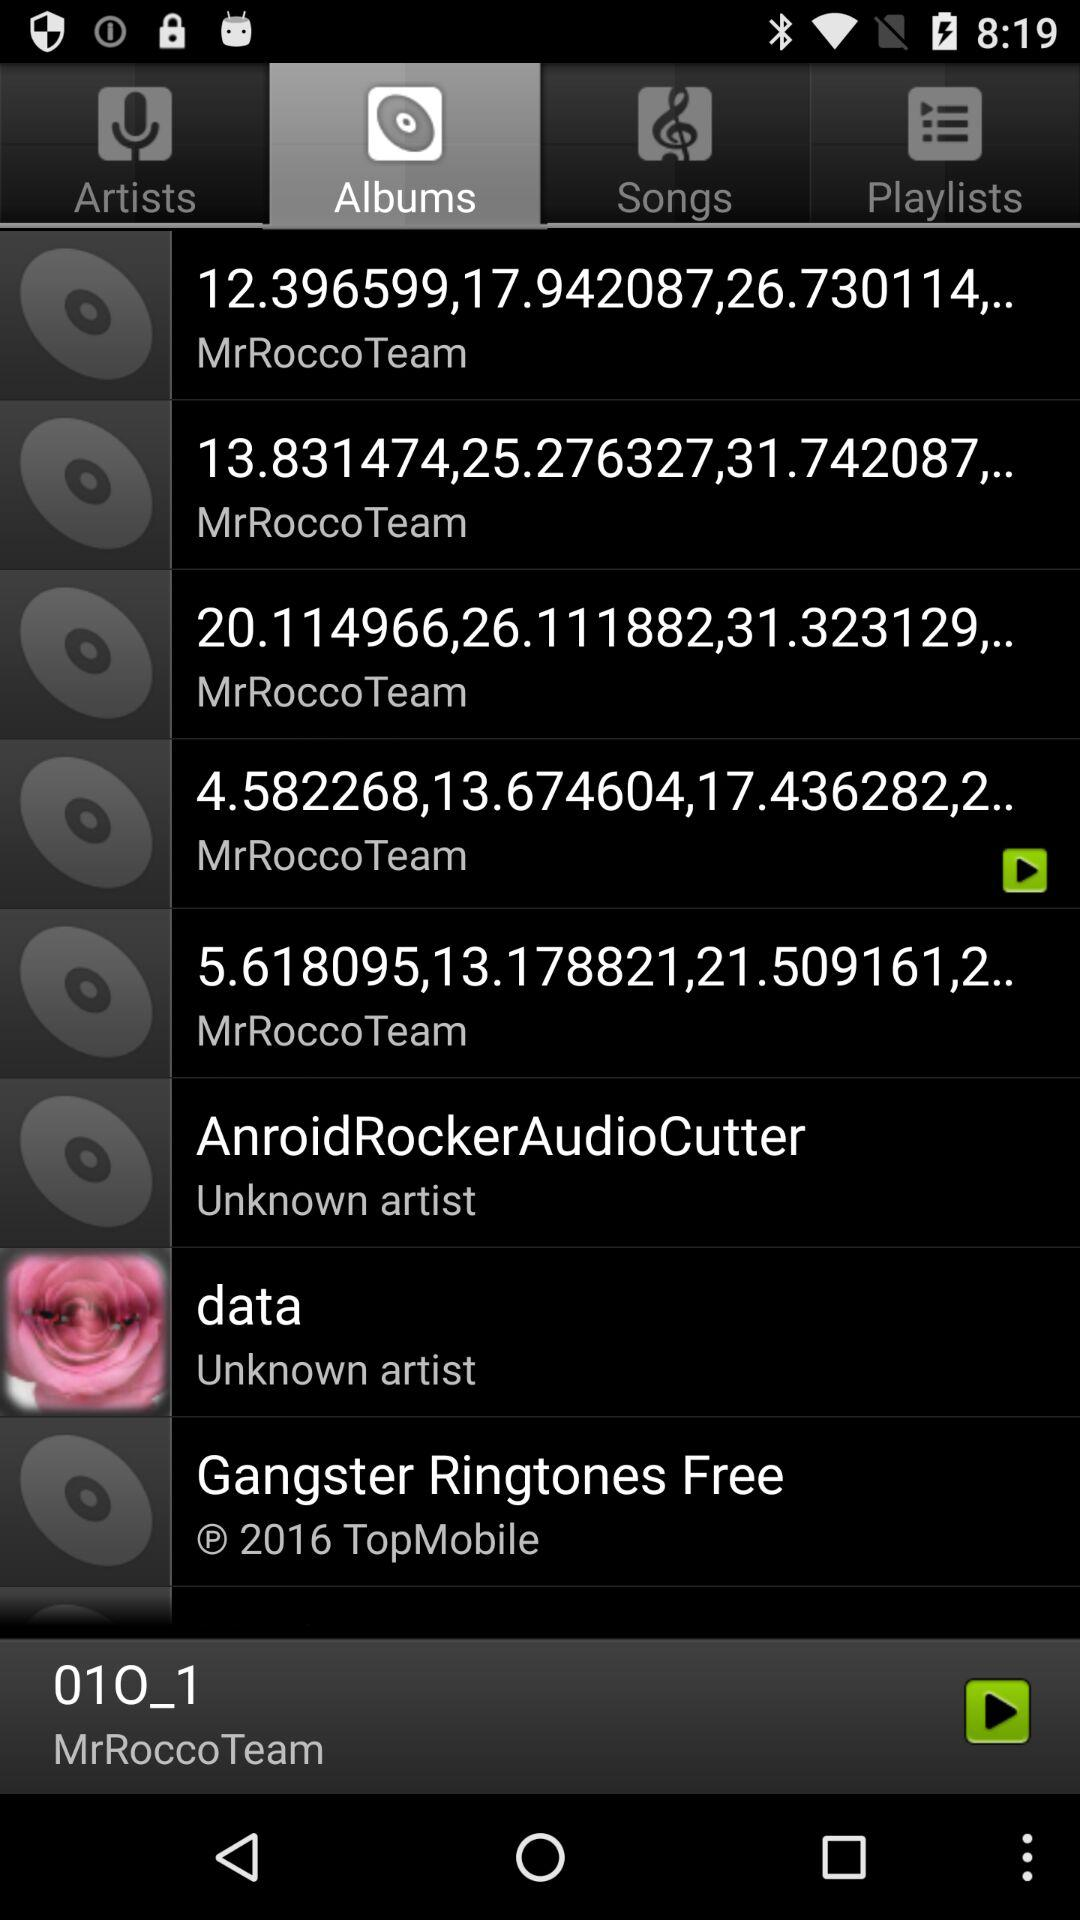Which tab has been selected? The selected tab is "Albums". 